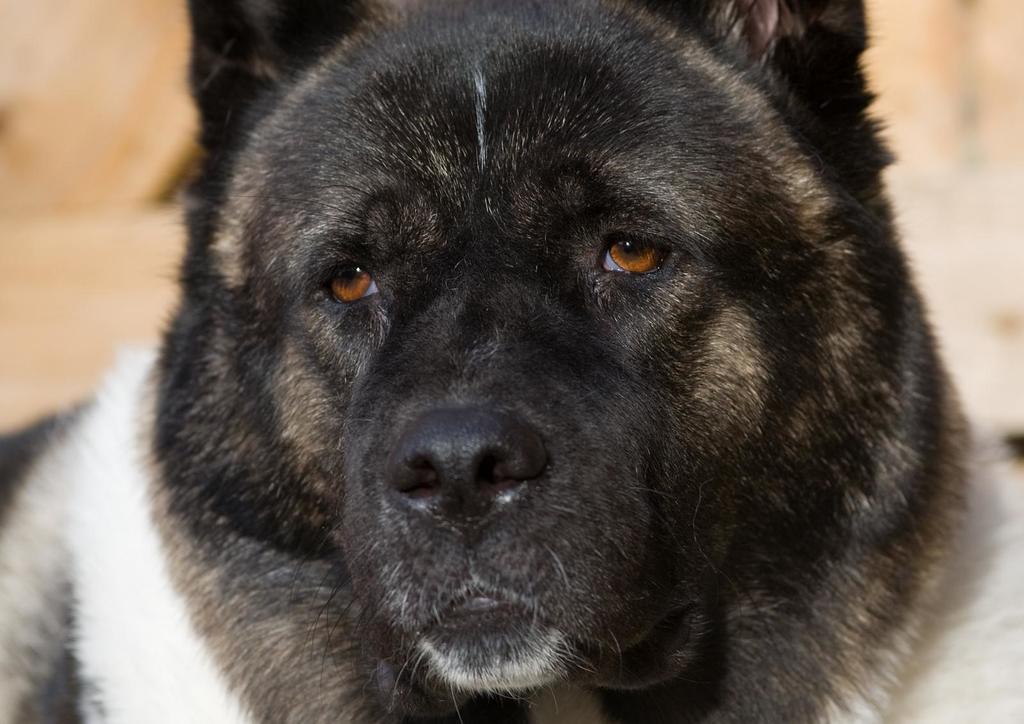Describe this image in one or two sentences. In this picture I can observe an animal in the middle of the picture. It is looking like a dog. This animal is in black and white color. The background is blurred. 